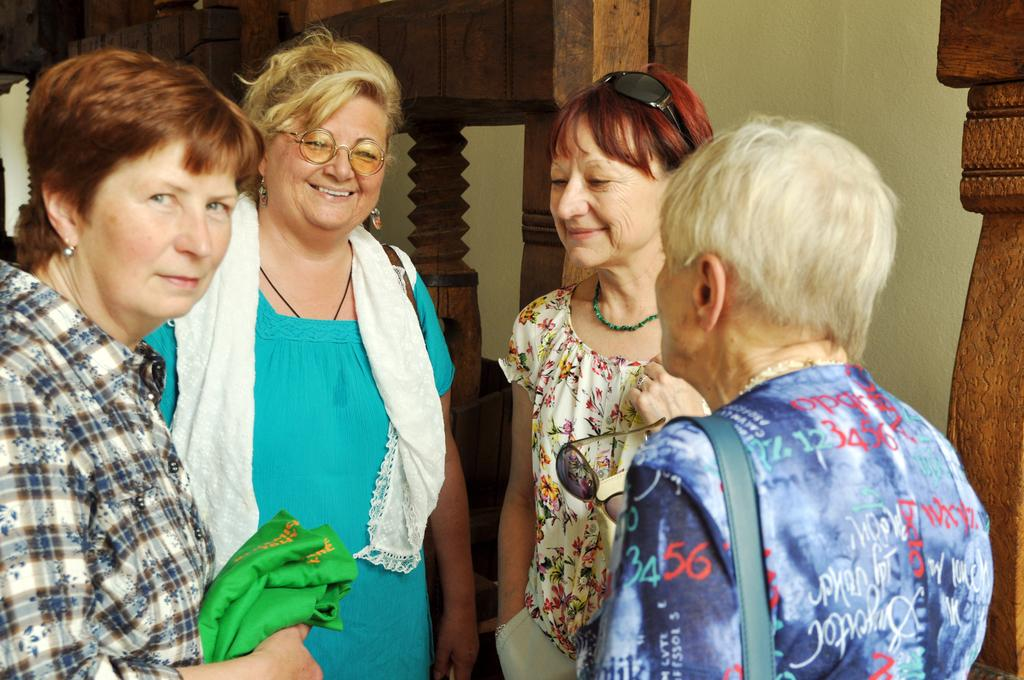How many women are present in the image? There are four women in the image. What can be observed about the women's attire? The women are wearing different color dresses. What are the women doing in the image? The women are standing. What type of elbow is visible in the image? There is no elbow visible in the image. What are the women cooking in the image? The image does not show the women cooking or any cooking-related activities. 